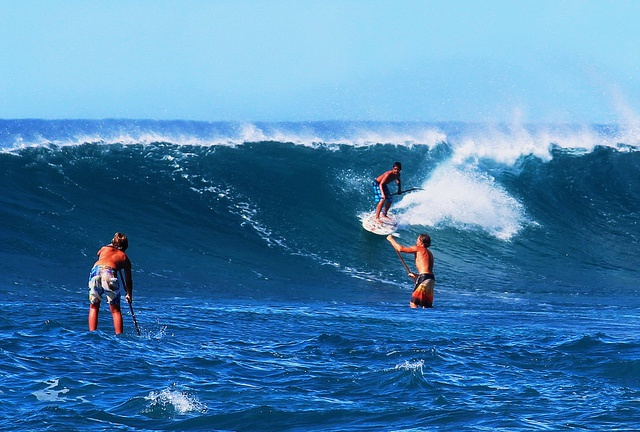Describe the objects in this image and their specific colors. I can see people in lightblue, black, navy, salmon, and lightgray tones, people in lightblue, black, maroon, salmon, and tan tones, people in lightblue, black, salmon, navy, and lightpink tones, and surfboard in lightblue, lightgray, darkgray, and pink tones in this image. 